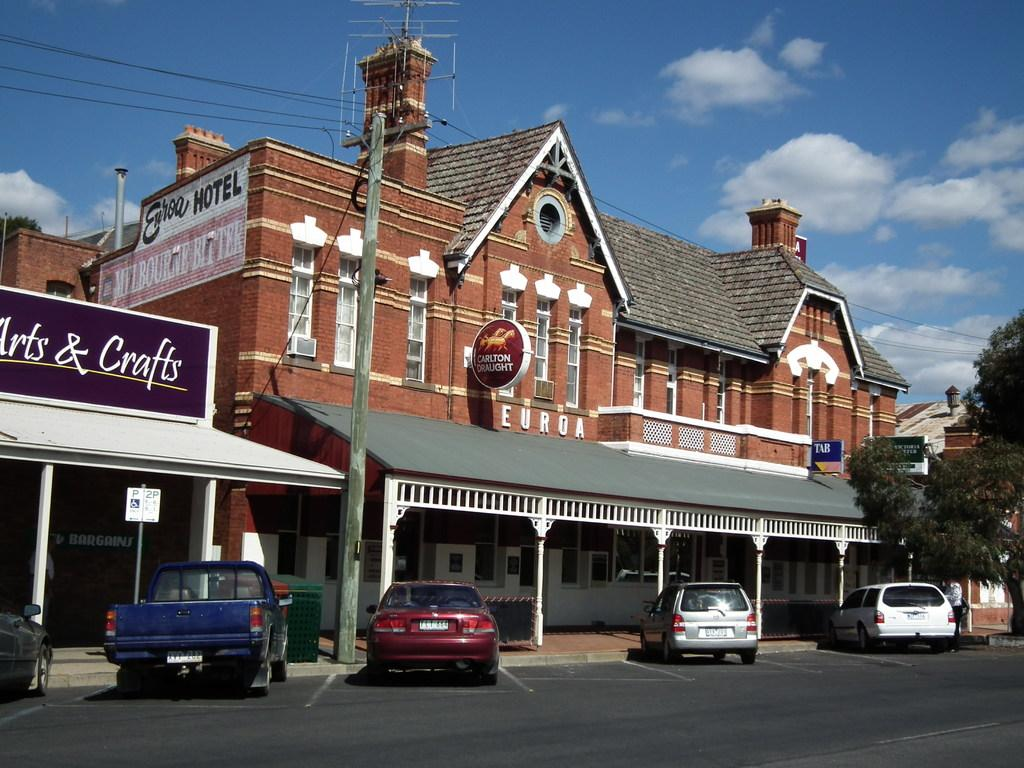What type of structures can be seen in the image? There are buildings in the image. What else can be seen in the image besides buildings? There are boards and trees visible in the image. What is the condition of the vehicles in the image? Vehicles are parked beside the road in the image. How is the sky depicted in the image? The sky is clouded in the image. Can you see the ocean in the image? No, there is no ocean present in the image. What type of stick is being used by the trees in the image? There are no sticks associated with the trees in the image; they are depicted as natural vegetation. 